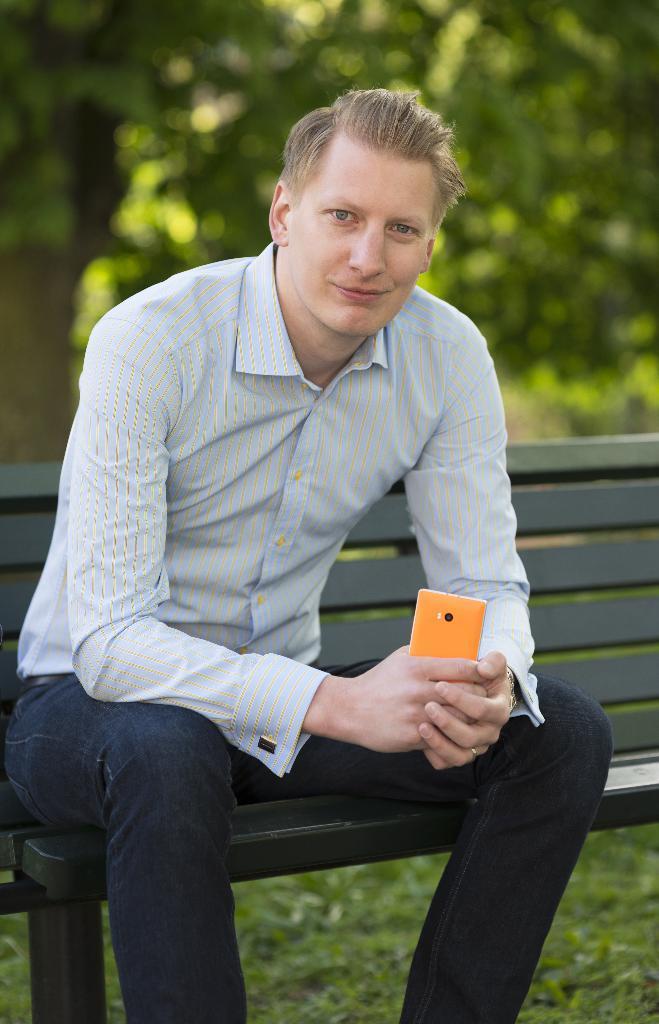Please provide a concise description of this image. In this picture we can see a man sitting on the bench and holding a mobile phone, in the bottom we can see grass and in the background there are some trees. 